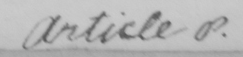Can you read and transcribe this handwriting? Article p . 